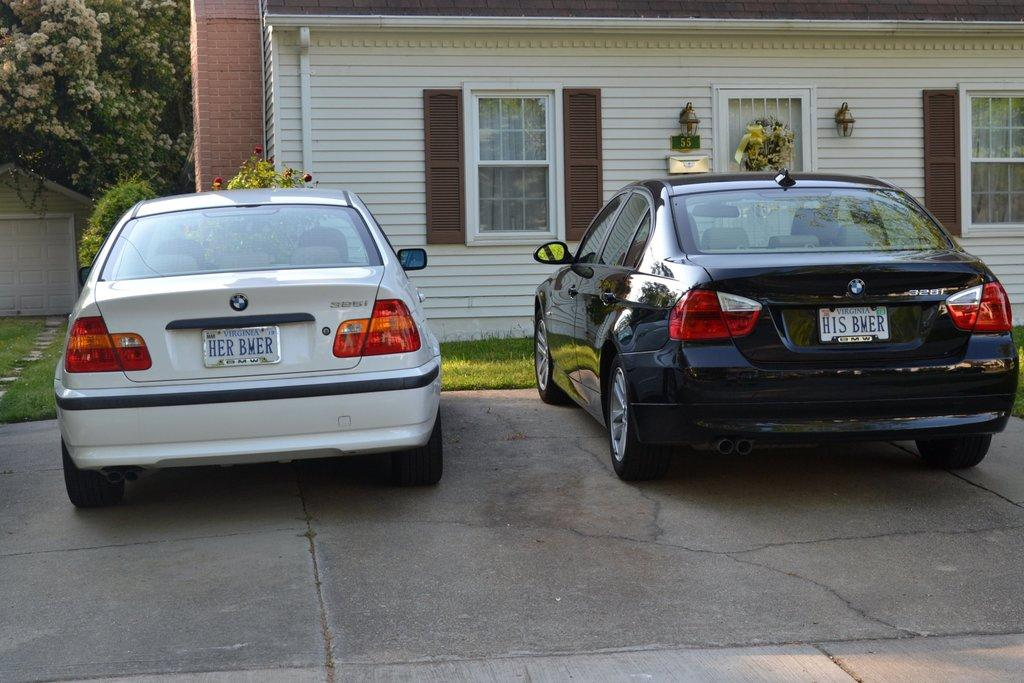<image>
Write a terse but informative summary of the picture. The license plates on two cars read HER BMER and HIS BMER. 